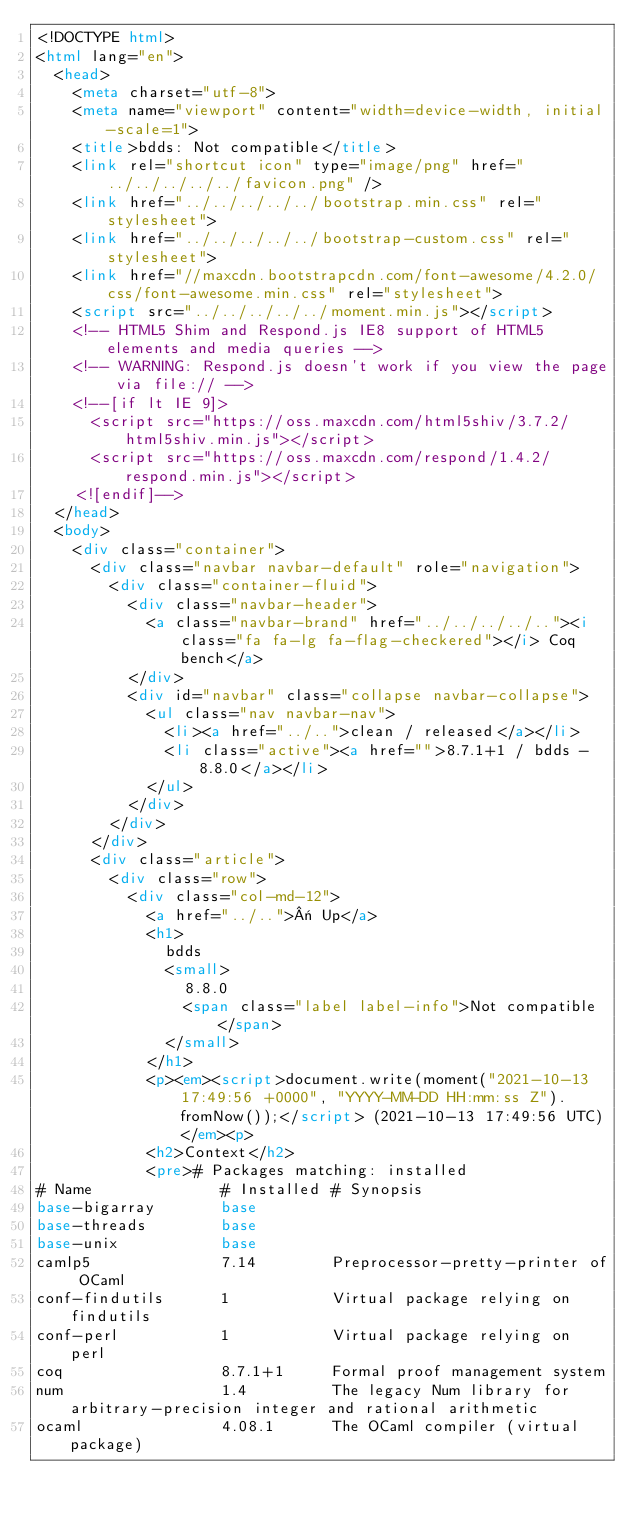Convert code to text. <code><loc_0><loc_0><loc_500><loc_500><_HTML_><!DOCTYPE html>
<html lang="en">
  <head>
    <meta charset="utf-8">
    <meta name="viewport" content="width=device-width, initial-scale=1">
    <title>bdds: Not compatible</title>
    <link rel="shortcut icon" type="image/png" href="../../../../../favicon.png" />
    <link href="../../../../../bootstrap.min.css" rel="stylesheet">
    <link href="../../../../../bootstrap-custom.css" rel="stylesheet">
    <link href="//maxcdn.bootstrapcdn.com/font-awesome/4.2.0/css/font-awesome.min.css" rel="stylesheet">
    <script src="../../../../../moment.min.js"></script>
    <!-- HTML5 Shim and Respond.js IE8 support of HTML5 elements and media queries -->
    <!-- WARNING: Respond.js doesn't work if you view the page via file:// -->
    <!--[if lt IE 9]>
      <script src="https://oss.maxcdn.com/html5shiv/3.7.2/html5shiv.min.js"></script>
      <script src="https://oss.maxcdn.com/respond/1.4.2/respond.min.js"></script>
    <![endif]-->
  </head>
  <body>
    <div class="container">
      <div class="navbar navbar-default" role="navigation">
        <div class="container-fluid">
          <div class="navbar-header">
            <a class="navbar-brand" href="../../../../.."><i class="fa fa-lg fa-flag-checkered"></i> Coq bench</a>
          </div>
          <div id="navbar" class="collapse navbar-collapse">
            <ul class="nav navbar-nav">
              <li><a href="../..">clean / released</a></li>
              <li class="active"><a href="">8.7.1+1 / bdds - 8.8.0</a></li>
            </ul>
          </div>
        </div>
      </div>
      <div class="article">
        <div class="row">
          <div class="col-md-12">
            <a href="../..">« Up</a>
            <h1>
              bdds
              <small>
                8.8.0
                <span class="label label-info">Not compatible</span>
              </small>
            </h1>
            <p><em><script>document.write(moment("2021-10-13 17:49:56 +0000", "YYYY-MM-DD HH:mm:ss Z").fromNow());</script> (2021-10-13 17:49:56 UTC)</em><p>
            <h2>Context</h2>
            <pre># Packages matching: installed
# Name              # Installed # Synopsis
base-bigarray       base
base-threads        base
base-unix           base
camlp5              7.14        Preprocessor-pretty-printer of OCaml
conf-findutils      1           Virtual package relying on findutils
conf-perl           1           Virtual package relying on perl
coq                 8.7.1+1     Formal proof management system
num                 1.4         The legacy Num library for arbitrary-precision integer and rational arithmetic
ocaml               4.08.1      The OCaml compiler (virtual package)</code> 